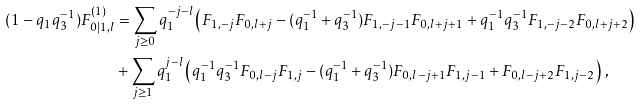Convert formula to latex. <formula><loc_0><loc_0><loc_500><loc_500>( 1 - q _ { 1 } q _ { 3 } ^ { - 1 } ) F ^ { ( 1 ) } _ { 0 | 1 , l } & = \sum _ { j \geq 0 } q _ { 1 } ^ { - j - l } \left ( F _ { 1 , - j } F _ { 0 , l + j } - ( q _ { 1 } ^ { - 1 } + q _ { 3 } ^ { - 1 } ) F _ { 1 , - j - 1 } F _ { 0 , l + j + 1 } + q _ { 1 } ^ { - 1 } q _ { 3 } ^ { - 1 } F _ { 1 , - j - 2 } F _ { 0 , l + j + 2 } \right ) \\ & + \sum _ { j \geq 1 } q _ { 1 } ^ { j - l } \left ( q _ { 1 } ^ { - 1 } q _ { 3 } ^ { - 1 } F _ { 0 , l - j } F _ { 1 , j } - ( q _ { 1 } ^ { - 1 } + q _ { 3 } ^ { - 1 } ) F _ { 0 , l - j + 1 } F _ { 1 , j - 1 } + F _ { 0 , l - j + 2 } F _ { 1 , j - 2 } \right ) \, ,</formula> 